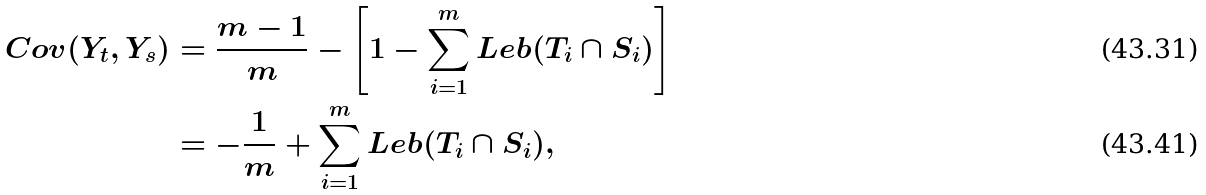<formula> <loc_0><loc_0><loc_500><loc_500>C o v ( Y _ { t } , Y _ { s } ) & = \frac { m - 1 } { m } - \left [ 1 - \sum ^ { m } _ { i = 1 } L e b ( T _ { i } \cap S _ { i } ) \right ] \\ & = - \frac { 1 } { m } + \sum ^ { m } _ { i = 1 } L e b ( T _ { i } \cap S _ { i } ) ,</formula> 